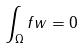<formula> <loc_0><loc_0><loc_500><loc_500>\int _ { \Omega } f w = 0</formula> 